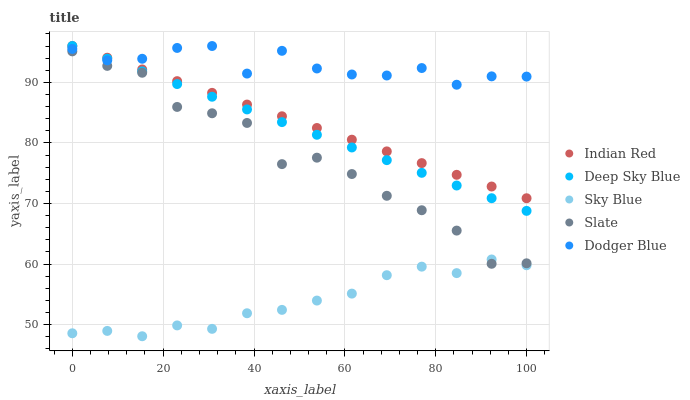Does Sky Blue have the minimum area under the curve?
Answer yes or no. Yes. Does Dodger Blue have the maximum area under the curve?
Answer yes or no. Yes. Does Slate have the minimum area under the curve?
Answer yes or no. No. Does Slate have the maximum area under the curve?
Answer yes or no. No. Is Indian Red the smoothest?
Answer yes or no. Yes. Is Dodger Blue the roughest?
Answer yes or no. Yes. Is Slate the smoothest?
Answer yes or no. No. Is Slate the roughest?
Answer yes or no. No. Does Sky Blue have the lowest value?
Answer yes or no. Yes. Does Slate have the lowest value?
Answer yes or no. No. Does Indian Red have the highest value?
Answer yes or no. Yes. Does Slate have the highest value?
Answer yes or no. No. Is Slate less than Indian Red?
Answer yes or no. Yes. Is Deep Sky Blue greater than Sky Blue?
Answer yes or no. Yes. Does Deep Sky Blue intersect Dodger Blue?
Answer yes or no. Yes. Is Deep Sky Blue less than Dodger Blue?
Answer yes or no. No. Is Deep Sky Blue greater than Dodger Blue?
Answer yes or no. No. Does Slate intersect Indian Red?
Answer yes or no. No. 